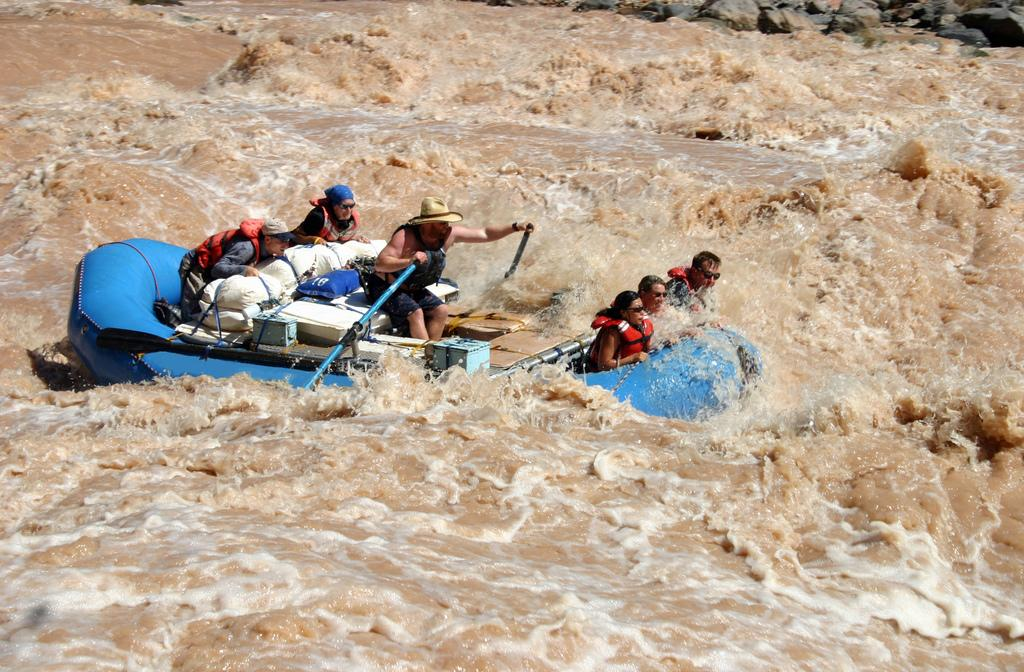What activity is taking place in the image? There is a river rafting scene in the image. How many people are participating in the activity? There are six people on the raft. What type of nut can be seen being cracked open by a drum in the image? There is no nut or drum present in the image; it features a river rafting scene with six people on the raft. 